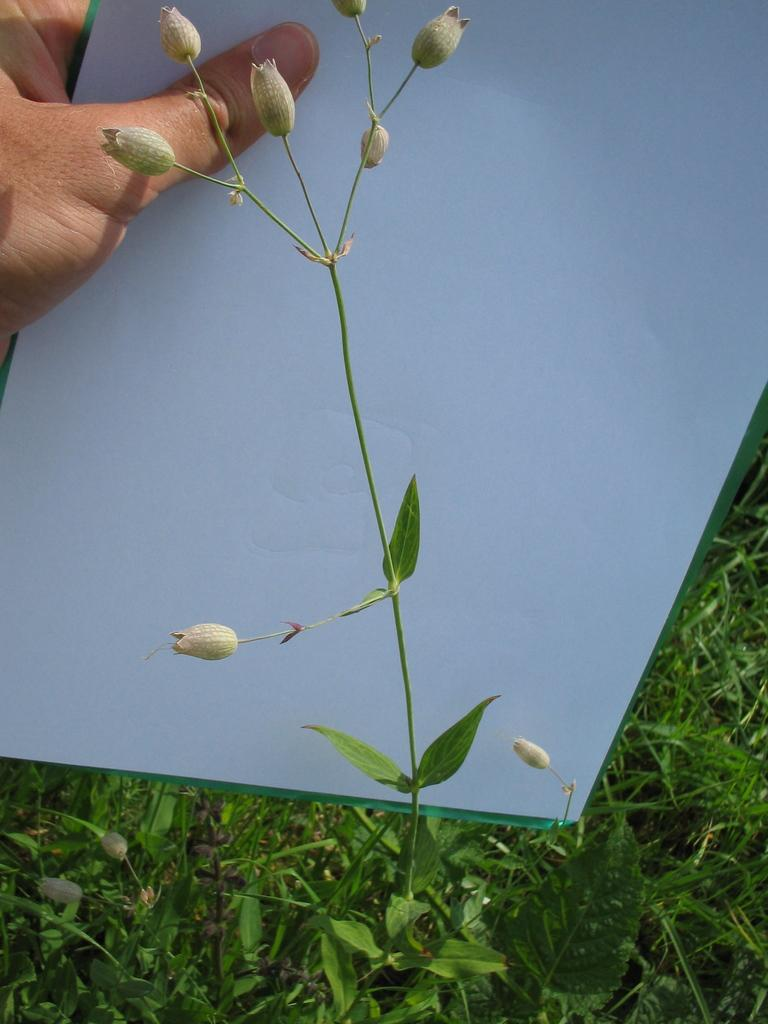What is the main subject in the center of the image? There is a plant with flowers in the center of the image. What type of vegetation can be seen in the background of the image? There is grass visible in the background of the image. What is the person in the background of the image holding? The person is holding a paper in the background of the image. How many horses are visible in the image? There are no horses present in the image. What type of tool is the person using to adjust the plant in the image? The person is not using any tool to adjust the plant in the image; they are simply holding a paper. 